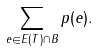<formula> <loc_0><loc_0><loc_500><loc_500>\sum _ { e \in E ( T ) \cap B } p ( e ) .</formula> 